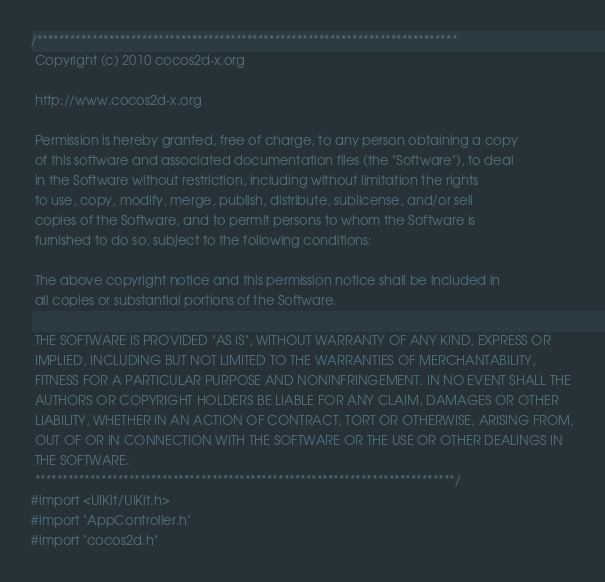Convert code to text. <code><loc_0><loc_0><loc_500><loc_500><_ObjectiveC_>/****************************************************************************
 Copyright (c) 2010 cocos2d-x.org

 http://www.cocos2d-x.org

 Permission is hereby granted, free of charge, to any person obtaining a copy
 of this software and associated documentation files (the "Software"), to deal
 in the Software without restriction, including without limitation the rights
 to use, copy, modify, merge, publish, distribute, sublicense, and/or sell
 copies of the Software, and to permit persons to whom the Software is
 furnished to do so, subject to the following conditions:

 The above copyright notice and this permission notice shall be included in
 all copies or substantial portions of the Software.

 THE SOFTWARE IS PROVIDED "AS IS", WITHOUT WARRANTY OF ANY KIND, EXPRESS OR
 IMPLIED, INCLUDING BUT NOT LIMITED TO THE WARRANTIES OF MERCHANTABILITY,
 FITNESS FOR A PARTICULAR PURPOSE AND NONINFRINGEMENT. IN NO EVENT SHALL THE
 AUTHORS OR COPYRIGHT HOLDERS BE LIABLE FOR ANY CLAIM, DAMAGES OR OTHER
 LIABILITY, WHETHER IN AN ACTION OF CONTRACT, TORT OR OTHERWISE, ARISING FROM,
 OUT OF OR IN CONNECTION WITH THE SOFTWARE OR THE USE OR OTHER DEALINGS IN
 THE SOFTWARE.
 ****************************************************************************/
#import <UIKit/UIKit.h>
#import "AppController.h"
#import "cocos2d.h"</code> 